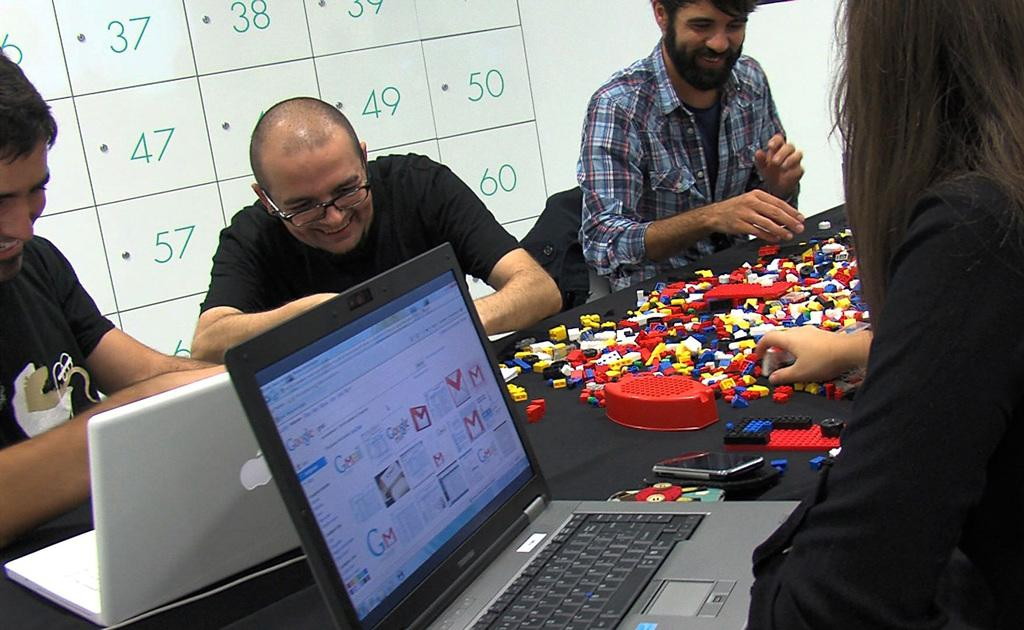<image>
Relay a brief, clear account of the picture shown. a google page open in a screen that is on a laptop 